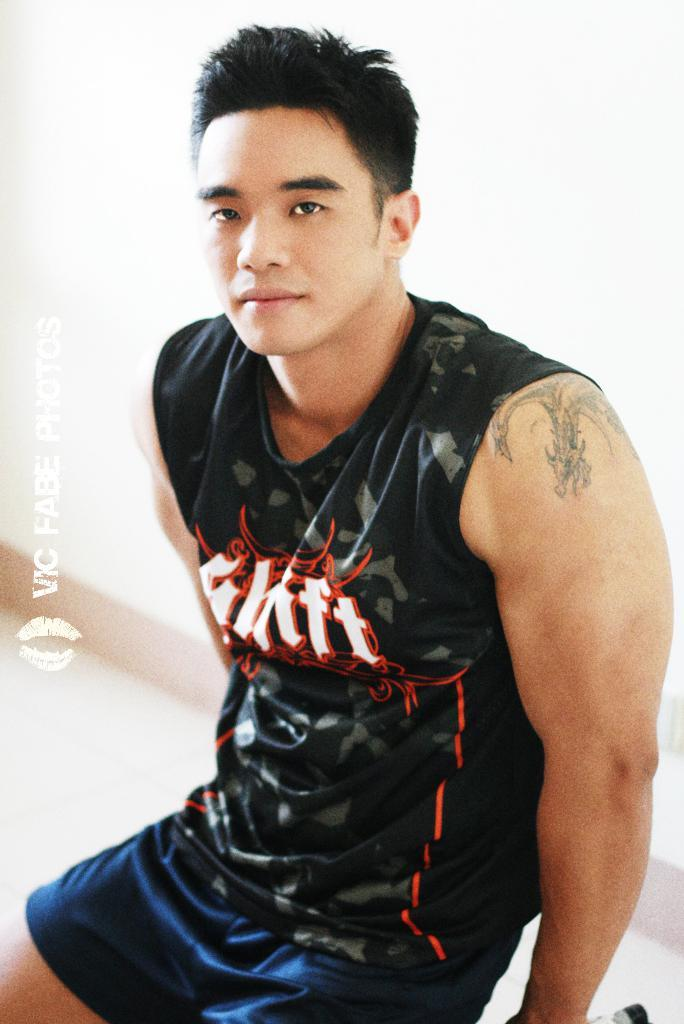Provide a one-sentence caption for the provided image. An Asian man wearing a sleeveless black tshirt with a logo reading Shift. 